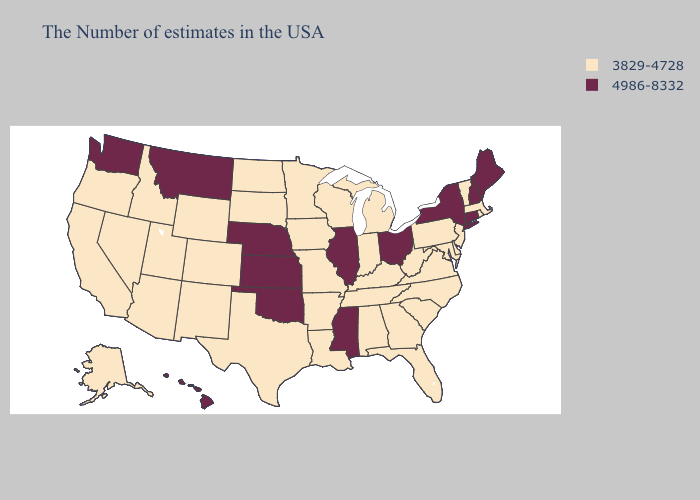Does the map have missing data?
Short answer required. No. Does Oklahoma have the highest value in the USA?
Concise answer only. Yes. Name the states that have a value in the range 4986-8332?
Be succinct. Maine, New Hampshire, Connecticut, New York, Ohio, Illinois, Mississippi, Kansas, Nebraska, Oklahoma, Montana, Washington, Hawaii. What is the lowest value in the USA?
Quick response, please. 3829-4728. Among the states that border Maine , which have the highest value?
Keep it brief. New Hampshire. Name the states that have a value in the range 4986-8332?
Answer briefly. Maine, New Hampshire, Connecticut, New York, Ohio, Illinois, Mississippi, Kansas, Nebraska, Oklahoma, Montana, Washington, Hawaii. Does Idaho have the highest value in the West?
Concise answer only. No. Name the states that have a value in the range 4986-8332?
Short answer required. Maine, New Hampshire, Connecticut, New York, Ohio, Illinois, Mississippi, Kansas, Nebraska, Oklahoma, Montana, Washington, Hawaii. What is the value of Vermont?
Give a very brief answer. 3829-4728. Name the states that have a value in the range 3829-4728?
Write a very short answer. Massachusetts, Rhode Island, Vermont, New Jersey, Delaware, Maryland, Pennsylvania, Virginia, North Carolina, South Carolina, West Virginia, Florida, Georgia, Michigan, Kentucky, Indiana, Alabama, Tennessee, Wisconsin, Louisiana, Missouri, Arkansas, Minnesota, Iowa, Texas, South Dakota, North Dakota, Wyoming, Colorado, New Mexico, Utah, Arizona, Idaho, Nevada, California, Oregon, Alaska. What is the value of South Dakota?
Answer briefly. 3829-4728. What is the value of Maryland?
Short answer required. 3829-4728. What is the highest value in states that border Connecticut?
Be succinct. 4986-8332. Which states hav the highest value in the MidWest?
Answer briefly. Ohio, Illinois, Kansas, Nebraska. What is the lowest value in states that border Mississippi?
Write a very short answer. 3829-4728. 